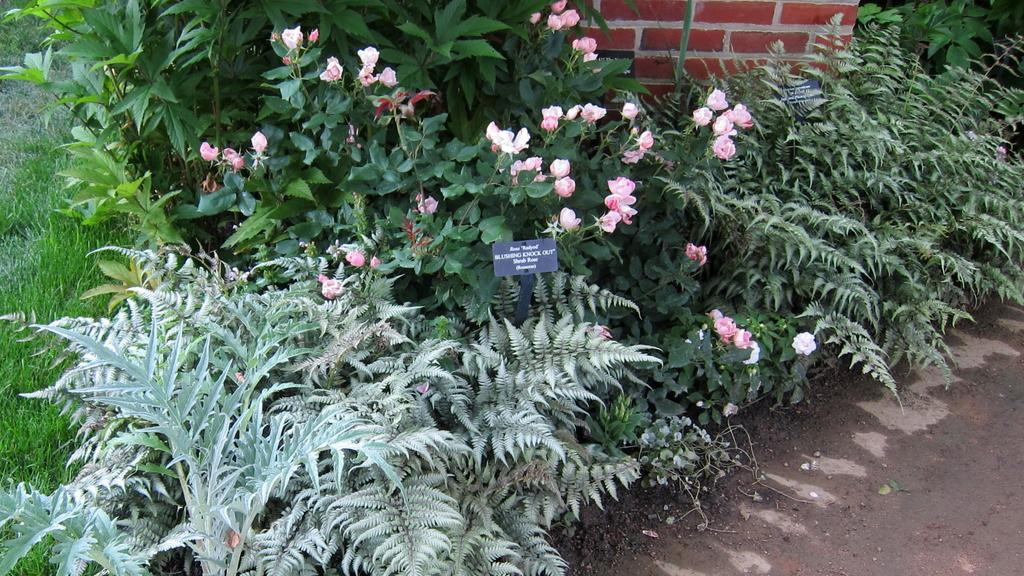What type of surface can be seen in the image? The ground is visible in the image. What type of vegetation is present in the image? There is grass, plants, and flowers in the image. Are there any signs or messages in the image? Yes, there are boards with text in the image. What type of structure is visible in the image? There is a wall in the image. How many baseballs can be seen in the image? There are no baseballs present in the image. What type of fruit is being used as a decoration in the image? There is no fruit, including bananas, being used as a decoration in the image. 